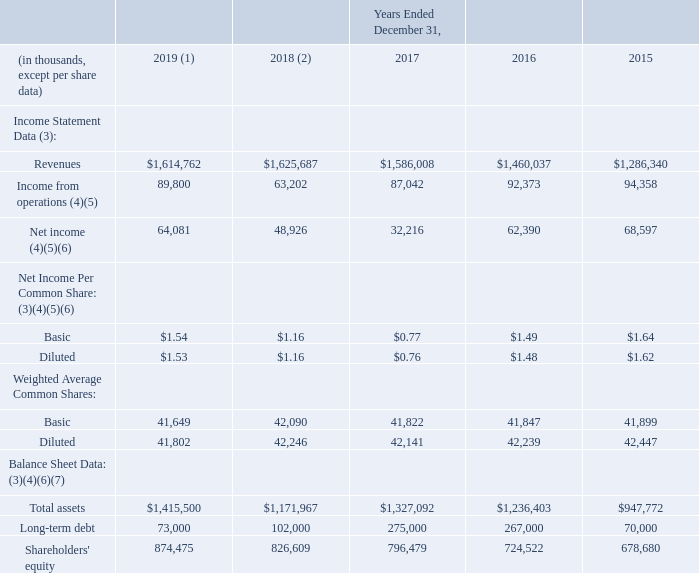Item 6. Selected Financial Data
The following selected financial data has been derived from our consolidated financial statements.
The information below should be read in conjunction with “Management’s Discussion and Analysis of Financial Condition and Results of Operations,” and the accompanying Consolidated Financial Statements and related notes thereto.
(1) Effective January 1, 2019, the Company adopted new guidance on leases using the modified retrospective method; as such, 2015 – 2018 have not been restated. See Note 3, Leases, of the accompanying “Notes to Consolidated Financial Statements” for further information.
(2) Effective January 1, 2018, the Company adopted new guidance on revenue recognition using the modified retrospective method; as such, 2015 – 2017 have not been restated. See Note 2, Revenues, of the accompanying “Notes to Consolidated Financial Statements” for further information.
(3) The amounts reflect the results of Symphony, WhistleOut, the Telecommunications Asset acquisition, Clearlink and Qelp since the associated acquisition dates of November 1, 2018, July 9, 2018, May 31, 2017, April 1, 2016 and July 2, 2015, respectively, as well as the related merger and integration costs incurred as part of each acquisition. See Note 4, Acquisitions, of the accompanying “Notes to Consolidated Financial Statements” for further information regarding the Symphony, WhistleOut and Telecommunications Asset acquisitions.
(4) The amounts for 2019, 2018 and 2017 include exit costs and impairments of long-lived assets. See Note 5, Costs Associated with Exit or Disposal Activities, and Note 6, Fair Value, of the accompanying “Notes to Consolidated Financial Statements” for further information.
(5) The amounts for 2018 include the $1.2 million Slaughter settlement agreement. See Note 22, Commitments and Loss Contingencies, of the accompanying “Notes to Consolidated Financial Statements” for further information.
(6) The amount for 2017 includes $32.7 million related to the impact of the 2017 Tax Reform Act. See Note 20, Income Taxes, of the accompanying “Notes to Consolidated Financial Statements” for further information.
(7) The Company has not declared cash dividends per common share for any of the five years presented.
In which years was the Income Statement Data provided for 2019, 2018, 2017, 2016, 2015. What is the basic net income per common share in 2019? $1.54. For which items in the table does the amount for 2017 includes the sum related to the impact of the 2017 Tax Reform Act? Net income, net income per common share, balance sheet data. In which year was the Diluted Net Income per Common Share largest? 1.62>1.53>1.48>1.16>0.76
Answer: 2015. What was the change in the basic net income per common share in 2019 from 2018? 1.54-1.16
Answer: 0.38. What was the percentage change in the basic net income per common share in 2019 from 2018?
Answer scale should be: percent. (1.54-1.16)/1.16
Answer: 32.76. 